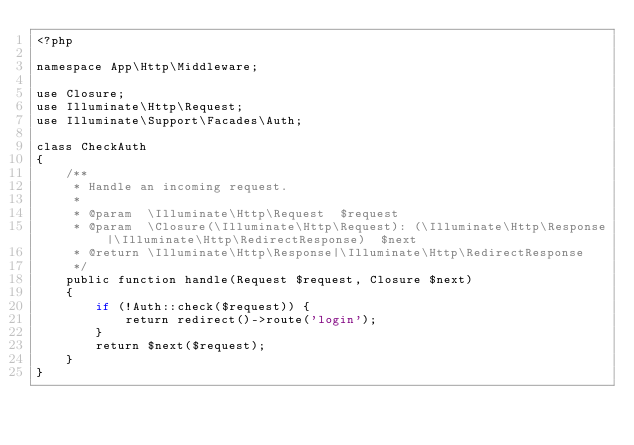<code> <loc_0><loc_0><loc_500><loc_500><_PHP_><?php

namespace App\Http\Middleware;

use Closure;
use Illuminate\Http\Request;
use Illuminate\Support\Facades\Auth;

class CheckAuth
{
    /**
     * Handle an incoming request.
     *
     * @param  \Illuminate\Http\Request  $request
     * @param  \Closure(\Illuminate\Http\Request): (\Illuminate\Http\Response|\Illuminate\Http\RedirectResponse)  $next
     * @return \Illuminate\Http\Response|\Illuminate\Http\RedirectResponse
     */
    public function handle(Request $request, Closure $next)
    {
        if (!Auth::check($request)) {
            return redirect()->route('login');
        }
        return $next($request);
    }
}
</code> 